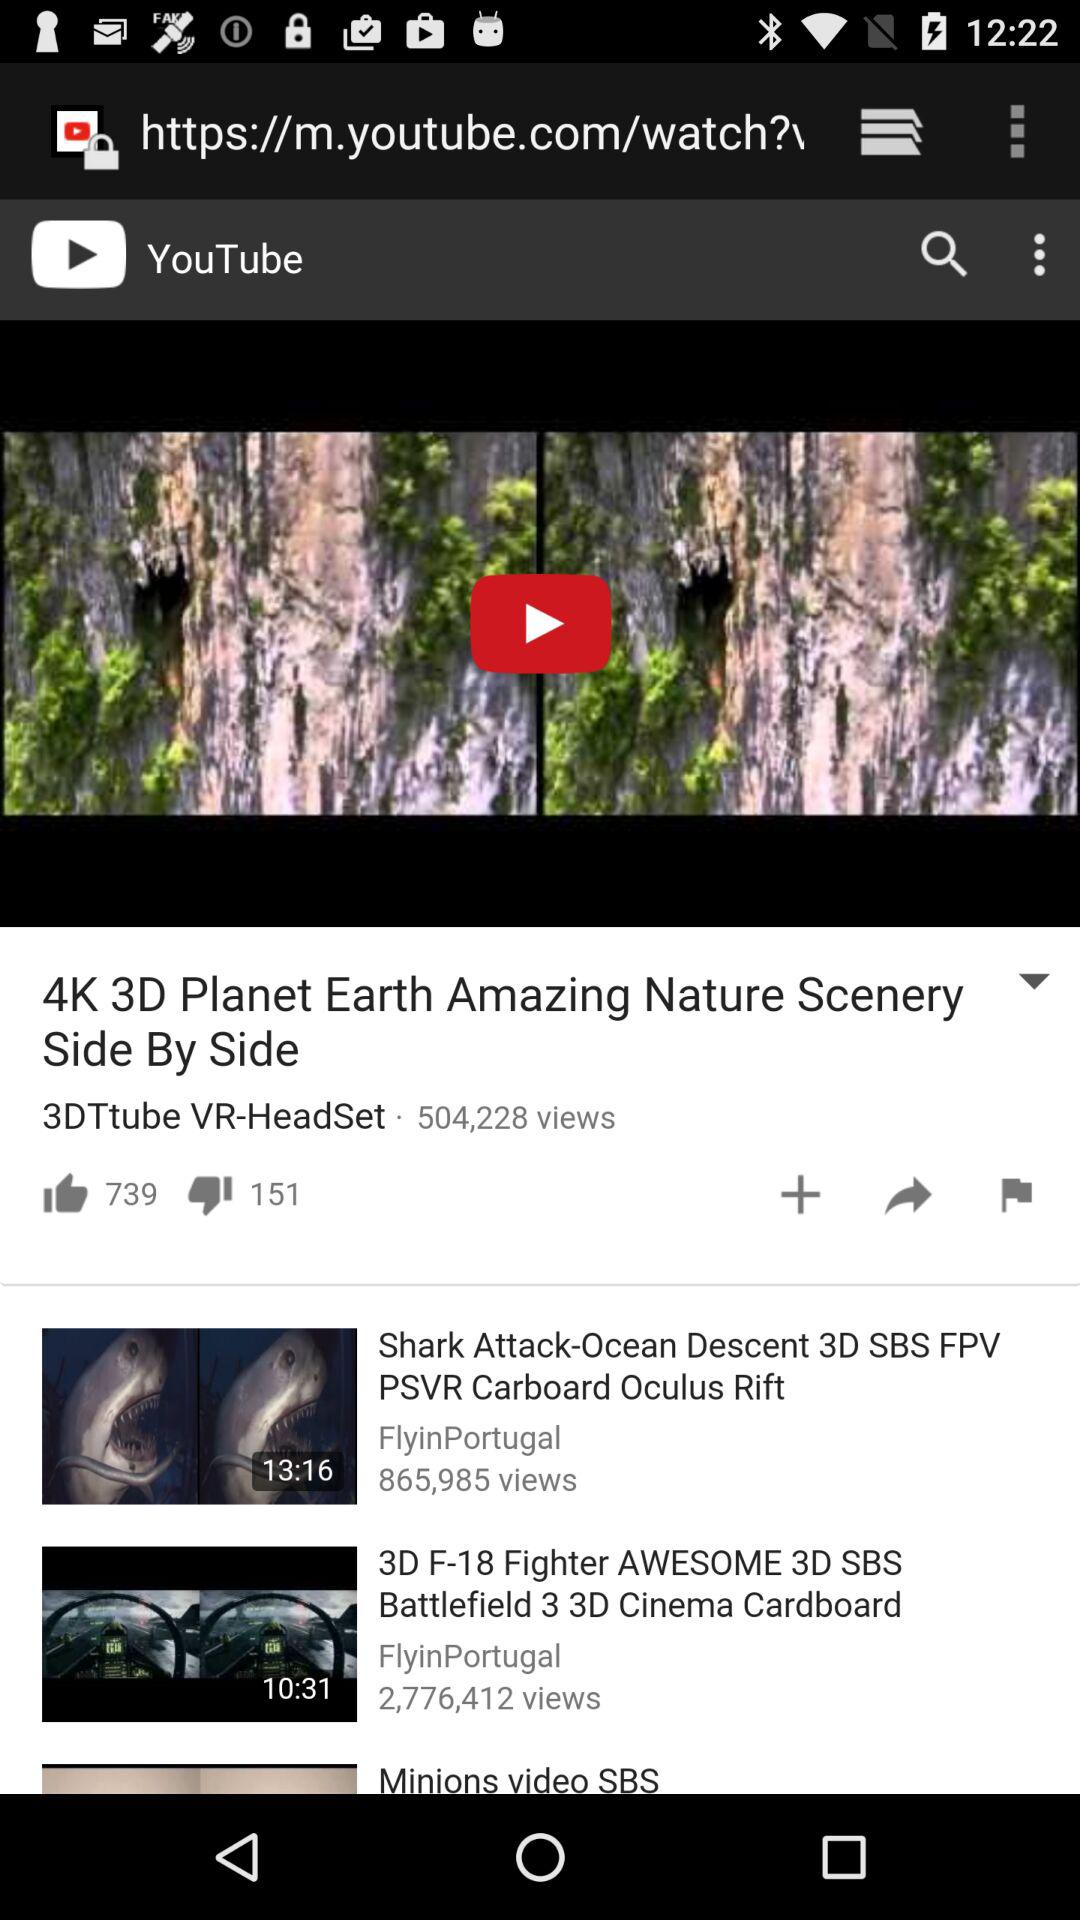How many views on the "4K 3D Planet Earth" video? The "4K 3D Planet Earth" video has 504,228 views. 